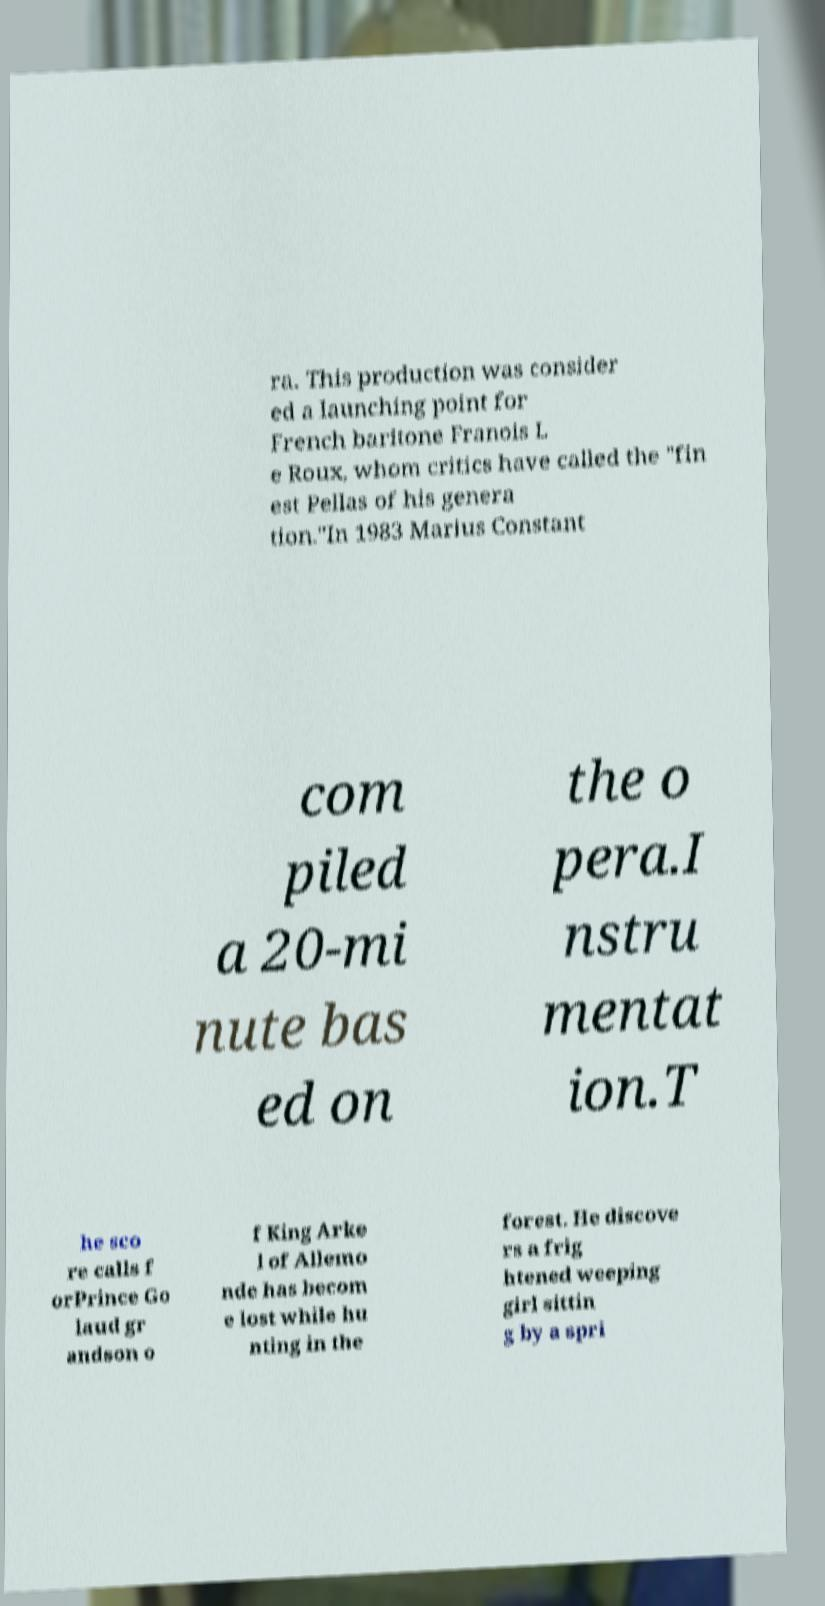There's text embedded in this image that I need extracted. Can you transcribe it verbatim? ra. This production was consider ed a launching point for French baritone Franois L e Roux, whom critics have called the "fin est Pellas of his genera tion."In 1983 Marius Constant com piled a 20-mi nute bas ed on the o pera.I nstru mentat ion.T he sco re calls f orPrince Go laud gr andson o f King Arke l of Allemo nde has becom e lost while hu nting in the forest. He discove rs a frig htened weeping girl sittin g by a spri 